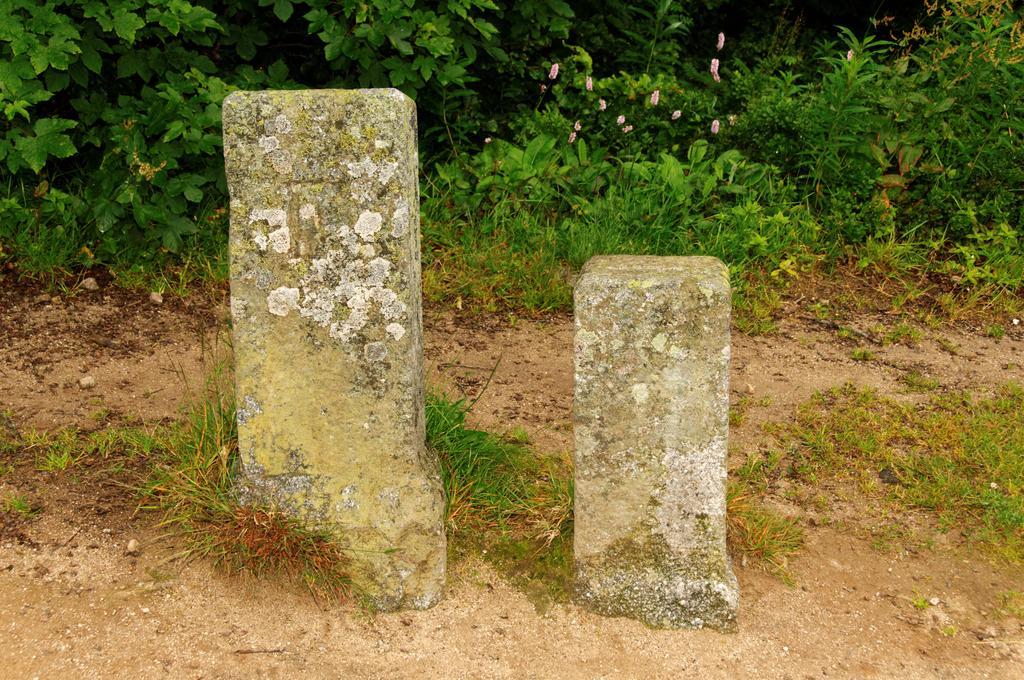Please provide a concise description of this image. In this image two pillars are on the land having some grass and plants. There are few flowers to the plants. 